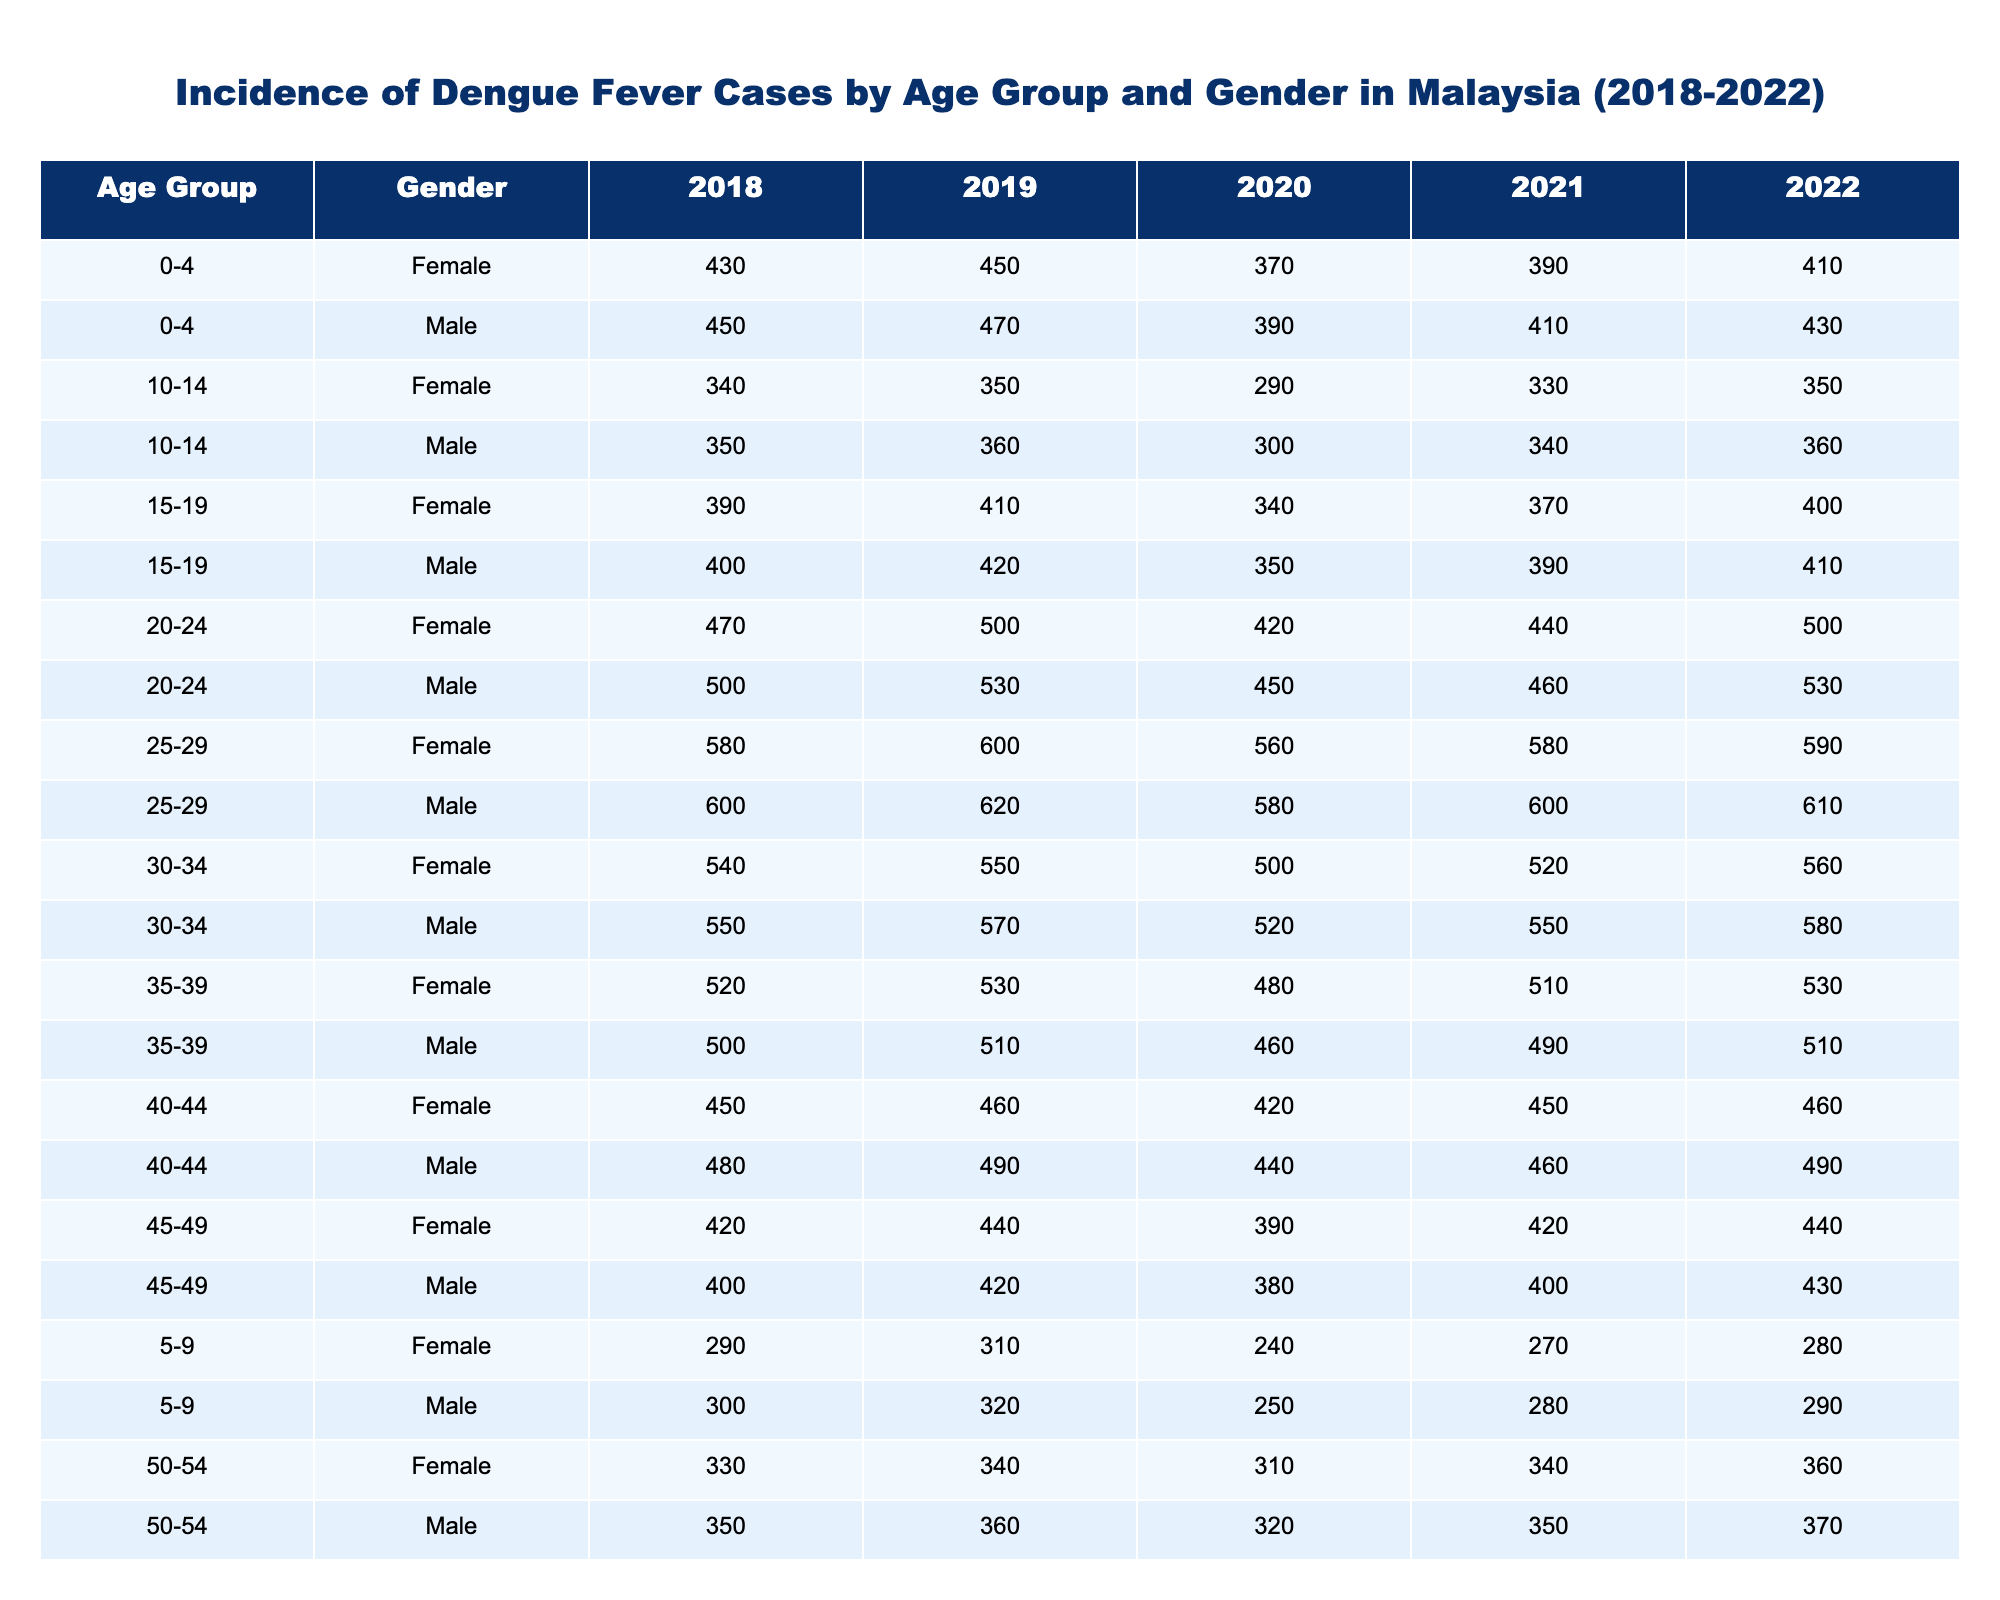What was the total number of dengue cases for males in the age group 20-24 in 2020? Referring to the table, the number of cases for males in the 20-24 age group for 2020 is 450.
Answer: 450 How many female cases were reported in the age group 30-34 across all years? Adding the values for female cases in the age group 30-34 from each year: 540 (2018) + 550 (2019) + 500 (2020) + 520 (2021) + 560 (2022) gives 540 + 550 + 500 + 520 + 560 = 2670.
Answer: 2670 Was there a year when the number of dengue cases for females in the age group 45-49 exceeded 450? Checking the table, the values for females aged 45-49 are: 420 (2018), 440 (2019), 390 (2020), 420 (2021), and 440 (2022). None of these exceeded 450.
Answer: No What is the difference in dengue cases for males in the age group 55-59 between the years 2018 and 2022? The male cases in the 55-59 age group for 2018 is 300, and for 2022 is 320. Therefore, the difference is 320 - 300 = 20.
Answer: 20 Which age group had the highest number of dengue cases for females in 2021? Analyzing the 2021 data: 430 (0-4), 270 (5-9), 330 (10-14), 370 (15-19), 440 (20-24), 580 (25-29), 520 (30-34), 510 (35-39), 450 (40-44), 420 (45-49), 340 (50-54), 300 (55-59), 250 (60+). The highest is 580 in the 25-29 age group.
Answer: 25-29 What percentage increase in dengue cases was observed for males in the age group 0-4 from 2019 to 2022? The male cases in the 0-4 age group were 470 in 2019 and 430 in 2022. The percentage increase is calculated as ((430 - 470) / 470) * 100 = (-40 / 470) * 100 ≈ -8.51%.
Answer: -8.51% In which year did the age group 15-19 for females experience the least number of dengue cases? Investigating the table, the cases for females in the 15-19 age group are: 390 (2018), 410 (2019), 340 (2020), 370 (2021), and 400 (2022). The least is 340 in 2020.
Answer: 2020 What is the average number of dengue cases for males in the 25-29 age group across all years? Summing the cases for males in the 25-29 age group: 600 (2018) + 620 (2019) + 580 (2020) + 600 (2021) + 610 (2022) = 3060. There are 5 data points, so the average is 3060 / 5 = 612.
Answer: 612 Which gender had more cases in the age group 40-44 in 2020? Looking at the table, the cases for males in 40-44 (440) and females in 40-44 (420) in 2020. Males had more cases than females.
Answer: Males How many cases were recorded for the age group 60+ for males over the years from 2018 to 2022 combined? Totaling the male cases in the 60+ age group for each year: 250 (2018) + 260 (2019) + 230 (2020) + 270 (2021) + 280 (2022) = 1290.
Answer: 1290 